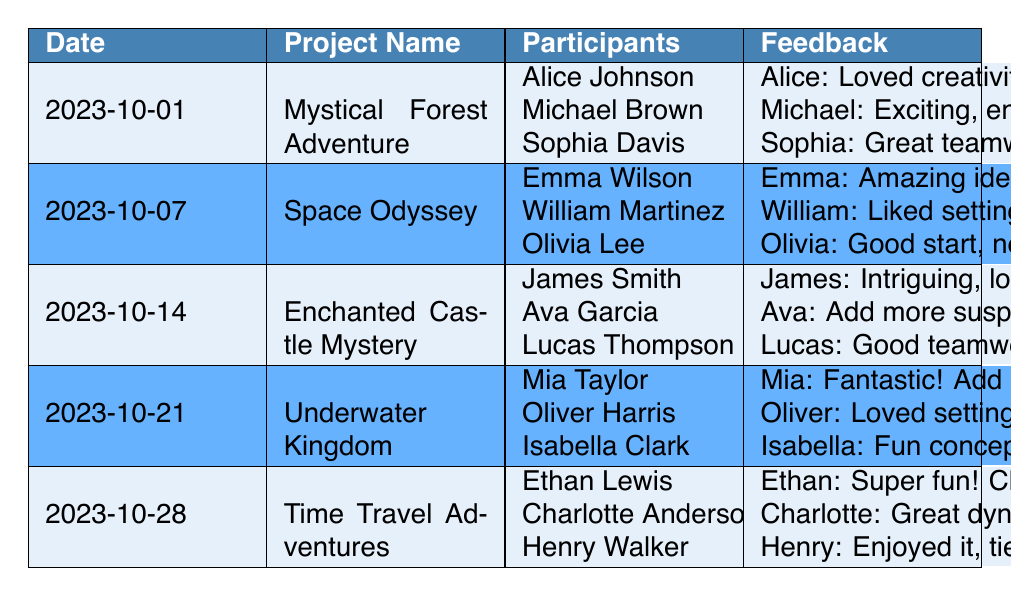What was the date of the project "Space Odyssey"? The table lists each project along with the corresponding date. For "Space Odyssey," it is found in the row indicating a date of "2023-10-07."
Answer: 2023-10-07 Who gave feedback on the "Underwater Kingdom" project? In the table, the "Underwater Kingdom" project row includes participants listed: Mia Taylor, Oliver Harris, and Isabella Clark. Their feedback follows their names.
Answer: Mia Taylor, Oliver Harris, Isabella Clark How many participants were involved in the "Enchanted Castle Mystery"? The "Enchanted Castle Mystery" project row shows three names under participants: James Smith, Ava Garcia, and Lucas Thompson. Therefore, the total count of participants is three.
Answer: 3 Did any participant suggest adding twists to the plot in their feedback? Looking through the feedback for each project, Alice Johnson specifically mentioned "add more twists" in her feedback for the "Mystical Forest Adventure." Thus, it is true that someone suggested this.
Answer: Yes Which project received feedback about needing clearer character motivations? The feedback for the "Space Odyssey" project mentions needing "clearer character motivations" from Olivia Lee. Hence, that project corresponds to the provided feedback.
Answer: Space Odyssey What is the average number of participants across all projects? There are five projects in total, each with three participants. Thus, the average is simply the total participants (3*5 = 15) divided by the number of projects (5), giving us an average of 3 participants per project.
Answer: 3 Which project had feedback about the story's pacing? The feedback for the "Mystical Forest Adventure" project includes a comment about improving pacing from Sophia Davis. Therefore, this project ties into the question regarding pacing.
Answer: Mystical Forest Adventure How many times did participants comment on character development? The term "character development" is mentioned once in the feedback for "Mystical Forest Adventure" by Michael Brown. It's not mentioned again in other projects' feedback.
Answer: 1 Which project was described as "super fun" by one of the participants? According to the feedback for the "Time Travel Adventures," Ethan Lewis explicitly described the project as "super fun." This confirms that it is the project in question.
Answer: Time Travel Adventures 